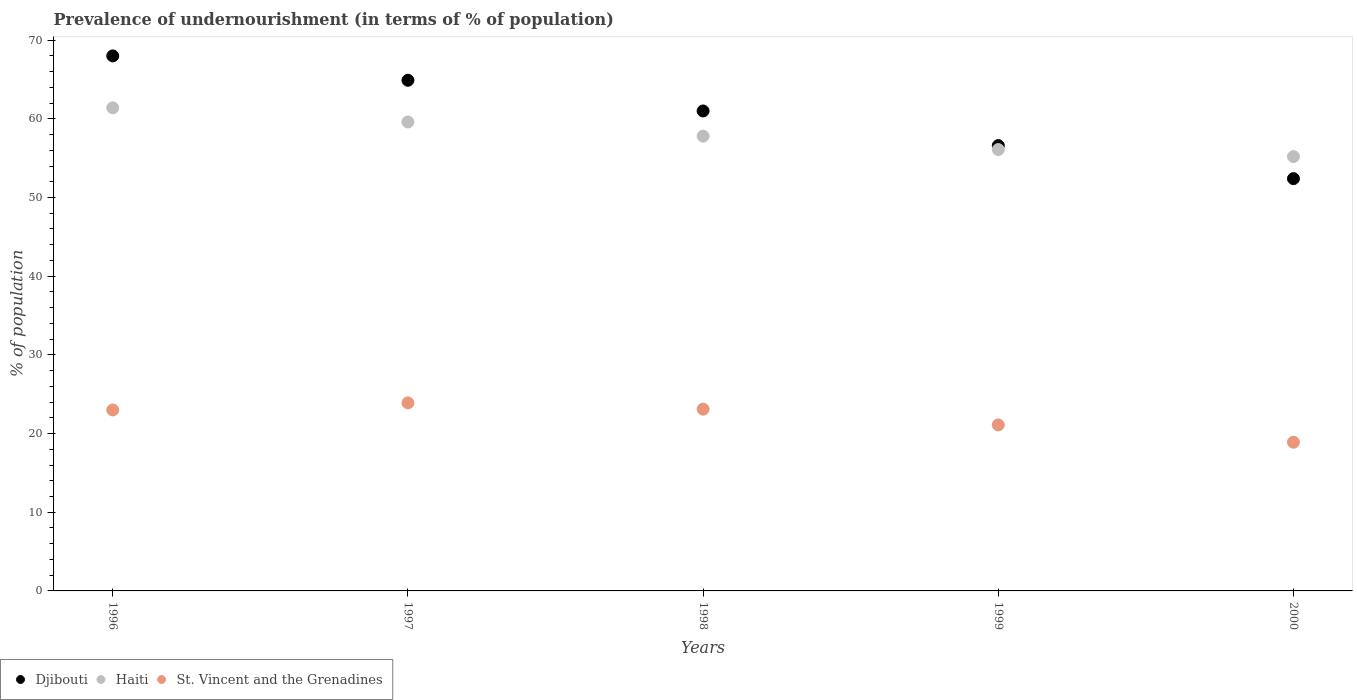Is the number of dotlines equal to the number of legend labels?
Give a very brief answer. Yes. What is the percentage of undernourished population in Haiti in 1997?
Your answer should be compact. 59.6. Across all years, what is the maximum percentage of undernourished population in St. Vincent and the Grenadines?
Offer a very short reply. 23.9. Across all years, what is the minimum percentage of undernourished population in Djibouti?
Your answer should be compact. 52.4. In which year was the percentage of undernourished population in Djibouti minimum?
Provide a succinct answer. 2000. What is the total percentage of undernourished population in Djibouti in the graph?
Your answer should be very brief. 302.9. What is the difference between the percentage of undernourished population in St. Vincent and the Grenadines in 1996 and that in 1999?
Your answer should be very brief. 1.9. What is the difference between the percentage of undernourished population in Djibouti in 1999 and the percentage of undernourished population in St. Vincent and the Grenadines in 1996?
Make the answer very short. 33.6. What is the average percentage of undernourished population in Haiti per year?
Your answer should be very brief. 58.02. In the year 1999, what is the difference between the percentage of undernourished population in Haiti and percentage of undernourished population in St. Vincent and the Grenadines?
Keep it short and to the point. 35. In how many years, is the percentage of undernourished population in Djibouti greater than 56 %?
Give a very brief answer. 4. What is the ratio of the percentage of undernourished population in St. Vincent and the Grenadines in 1997 to that in 1998?
Offer a terse response. 1.03. What is the difference between the highest and the second highest percentage of undernourished population in Haiti?
Offer a very short reply. 1.8. What is the difference between the highest and the lowest percentage of undernourished population in Haiti?
Your answer should be compact. 6.2. In how many years, is the percentage of undernourished population in Djibouti greater than the average percentage of undernourished population in Djibouti taken over all years?
Offer a terse response. 3. Is the sum of the percentage of undernourished population in Djibouti in 1997 and 1998 greater than the maximum percentage of undernourished population in Haiti across all years?
Your answer should be very brief. Yes. Does the percentage of undernourished population in Djibouti monotonically increase over the years?
Provide a short and direct response. No. Is the percentage of undernourished population in Haiti strictly less than the percentage of undernourished population in St. Vincent and the Grenadines over the years?
Offer a very short reply. No. How many dotlines are there?
Provide a short and direct response. 3. How many years are there in the graph?
Your answer should be compact. 5. What is the difference between two consecutive major ticks on the Y-axis?
Give a very brief answer. 10. Are the values on the major ticks of Y-axis written in scientific E-notation?
Keep it short and to the point. No. Does the graph contain any zero values?
Provide a succinct answer. No. Does the graph contain grids?
Make the answer very short. No. Where does the legend appear in the graph?
Offer a terse response. Bottom left. How are the legend labels stacked?
Offer a terse response. Horizontal. What is the title of the graph?
Make the answer very short. Prevalence of undernourishment (in terms of % of population). Does "Eritrea" appear as one of the legend labels in the graph?
Make the answer very short. No. What is the label or title of the Y-axis?
Your answer should be compact. % of population. What is the % of population of Haiti in 1996?
Ensure brevity in your answer.  61.4. What is the % of population of St. Vincent and the Grenadines in 1996?
Offer a very short reply. 23. What is the % of population of Djibouti in 1997?
Provide a short and direct response. 64.9. What is the % of population in Haiti in 1997?
Offer a very short reply. 59.6. What is the % of population in St. Vincent and the Grenadines in 1997?
Keep it short and to the point. 23.9. What is the % of population in Haiti in 1998?
Make the answer very short. 57.8. What is the % of population of St. Vincent and the Grenadines in 1998?
Give a very brief answer. 23.1. What is the % of population of Djibouti in 1999?
Make the answer very short. 56.6. What is the % of population of Haiti in 1999?
Your answer should be very brief. 56.1. What is the % of population of St. Vincent and the Grenadines in 1999?
Your response must be concise. 21.1. What is the % of population of Djibouti in 2000?
Your answer should be very brief. 52.4. What is the % of population in Haiti in 2000?
Ensure brevity in your answer.  55.2. Across all years, what is the maximum % of population of Djibouti?
Provide a succinct answer. 68. Across all years, what is the maximum % of population of Haiti?
Provide a succinct answer. 61.4. Across all years, what is the maximum % of population of St. Vincent and the Grenadines?
Offer a very short reply. 23.9. Across all years, what is the minimum % of population in Djibouti?
Provide a short and direct response. 52.4. Across all years, what is the minimum % of population in Haiti?
Keep it short and to the point. 55.2. What is the total % of population of Djibouti in the graph?
Offer a terse response. 302.9. What is the total % of population of Haiti in the graph?
Provide a short and direct response. 290.1. What is the total % of population in St. Vincent and the Grenadines in the graph?
Your answer should be compact. 110. What is the difference between the % of population of Haiti in 1996 and that in 1997?
Your answer should be very brief. 1.8. What is the difference between the % of population in St. Vincent and the Grenadines in 1996 and that in 1997?
Ensure brevity in your answer.  -0.9. What is the difference between the % of population in Djibouti in 1996 and that in 1998?
Provide a short and direct response. 7. What is the difference between the % of population in Haiti in 1996 and that in 1998?
Provide a short and direct response. 3.6. What is the difference between the % of population in St. Vincent and the Grenadines in 1996 and that in 1998?
Keep it short and to the point. -0.1. What is the difference between the % of population of Djibouti in 1996 and that in 2000?
Provide a succinct answer. 15.6. What is the difference between the % of population in Djibouti in 1997 and that in 1998?
Provide a short and direct response. 3.9. What is the difference between the % of population in St. Vincent and the Grenadines in 1997 and that in 2000?
Ensure brevity in your answer.  5. What is the difference between the % of population in Haiti in 1998 and that in 1999?
Your answer should be compact. 1.7. What is the difference between the % of population in St. Vincent and the Grenadines in 1998 and that in 1999?
Offer a very short reply. 2. What is the difference between the % of population in Djibouti in 1998 and that in 2000?
Provide a succinct answer. 8.6. What is the difference between the % of population in St. Vincent and the Grenadines in 1998 and that in 2000?
Provide a short and direct response. 4.2. What is the difference between the % of population of St. Vincent and the Grenadines in 1999 and that in 2000?
Ensure brevity in your answer.  2.2. What is the difference between the % of population of Djibouti in 1996 and the % of population of St. Vincent and the Grenadines in 1997?
Ensure brevity in your answer.  44.1. What is the difference between the % of population in Haiti in 1996 and the % of population in St. Vincent and the Grenadines in 1997?
Offer a very short reply. 37.5. What is the difference between the % of population in Djibouti in 1996 and the % of population in St. Vincent and the Grenadines in 1998?
Your answer should be compact. 44.9. What is the difference between the % of population in Haiti in 1996 and the % of population in St. Vincent and the Grenadines in 1998?
Give a very brief answer. 38.3. What is the difference between the % of population of Djibouti in 1996 and the % of population of Haiti in 1999?
Ensure brevity in your answer.  11.9. What is the difference between the % of population in Djibouti in 1996 and the % of population in St. Vincent and the Grenadines in 1999?
Your answer should be very brief. 46.9. What is the difference between the % of population in Haiti in 1996 and the % of population in St. Vincent and the Grenadines in 1999?
Offer a terse response. 40.3. What is the difference between the % of population of Djibouti in 1996 and the % of population of Haiti in 2000?
Your answer should be compact. 12.8. What is the difference between the % of population of Djibouti in 1996 and the % of population of St. Vincent and the Grenadines in 2000?
Your answer should be very brief. 49.1. What is the difference between the % of population of Haiti in 1996 and the % of population of St. Vincent and the Grenadines in 2000?
Keep it short and to the point. 42.5. What is the difference between the % of population of Djibouti in 1997 and the % of population of Haiti in 1998?
Keep it short and to the point. 7.1. What is the difference between the % of population in Djibouti in 1997 and the % of population in St. Vincent and the Grenadines in 1998?
Provide a short and direct response. 41.8. What is the difference between the % of population of Haiti in 1997 and the % of population of St. Vincent and the Grenadines in 1998?
Your answer should be very brief. 36.5. What is the difference between the % of population of Djibouti in 1997 and the % of population of Haiti in 1999?
Your answer should be compact. 8.8. What is the difference between the % of population of Djibouti in 1997 and the % of population of St. Vincent and the Grenadines in 1999?
Keep it short and to the point. 43.8. What is the difference between the % of population in Haiti in 1997 and the % of population in St. Vincent and the Grenadines in 1999?
Your answer should be compact. 38.5. What is the difference between the % of population of Djibouti in 1997 and the % of population of Haiti in 2000?
Your answer should be compact. 9.7. What is the difference between the % of population in Djibouti in 1997 and the % of population in St. Vincent and the Grenadines in 2000?
Your answer should be very brief. 46. What is the difference between the % of population of Haiti in 1997 and the % of population of St. Vincent and the Grenadines in 2000?
Offer a very short reply. 40.7. What is the difference between the % of population of Djibouti in 1998 and the % of population of Haiti in 1999?
Your answer should be very brief. 4.9. What is the difference between the % of population in Djibouti in 1998 and the % of population in St. Vincent and the Grenadines in 1999?
Give a very brief answer. 39.9. What is the difference between the % of population in Haiti in 1998 and the % of population in St. Vincent and the Grenadines in 1999?
Offer a very short reply. 36.7. What is the difference between the % of population in Djibouti in 1998 and the % of population in St. Vincent and the Grenadines in 2000?
Offer a very short reply. 42.1. What is the difference between the % of population in Haiti in 1998 and the % of population in St. Vincent and the Grenadines in 2000?
Ensure brevity in your answer.  38.9. What is the difference between the % of population of Djibouti in 1999 and the % of population of St. Vincent and the Grenadines in 2000?
Give a very brief answer. 37.7. What is the difference between the % of population in Haiti in 1999 and the % of population in St. Vincent and the Grenadines in 2000?
Your response must be concise. 37.2. What is the average % of population of Djibouti per year?
Provide a short and direct response. 60.58. What is the average % of population of Haiti per year?
Give a very brief answer. 58.02. In the year 1996, what is the difference between the % of population in Djibouti and % of population in Haiti?
Your answer should be compact. 6.6. In the year 1996, what is the difference between the % of population of Haiti and % of population of St. Vincent and the Grenadines?
Your response must be concise. 38.4. In the year 1997, what is the difference between the % of population in Djibouti and % of population in Haiti?
Offer a very short reply. 5.3. In the year 1997, what is the difference between the % of population in Djibouti and % of population in St. Vincent and the Grenadines?
Provide a succinct answer. 41. In the year 1997, what is the difference between the % of population in Haiti and % of population in St. Vincent and the Grenadines?
Keep it short and to the point. 35.7. In the year 1998, what is the difference between the % of population in Djibouti and % of population in Haiti?
Give a very brief answer. 3.2. In the year 1998, what is the difference between the % of population in Djibouti and % of population in St. Vincent and the Grenadines?
Offer a terse response. 37.9. In the year 1998, what is the difference between the % of population of Haiti and % of population of St. Vincent and the Grenadines?
Make the answer very short. 34.7. In the year 1999, what is the difference between the % of population in Djibouti and % of population in Haiti?
Offer a terse response. 0.5. In the year 1999, what is the difference between the % of population in Djibouti and % of population in St. Vincent and the Grenadines?
Provide a short and direct response. 35.5. In the year 1999, what is the difference between the % of population in Haiti and % of population in St. Vincent and the Grenadines?
Provide a succinct answer. 35. In the year 2000, what is the difference between the % of population of Djibouti and % of population of St. Vincent and the Grenadines?
Make the answer very short. 33.5. In the year 2000, what is the difference between the % of population of Haiti and % of population of St. Vincent and the Grenadines?
Your answer should be very brief. 36.3. What is the ratio of the % of population in Djibouti in 1996 to that in 1997?
Your response must be concise. 1.05. What is the ratio of the % of population of Haiti in 1996 to that in 1997?
Your answer should be compact. 1.03. What is the ratio of the % of population of St. Vincent and the Grenadines in 1996 to that in 1997?
Make the answer very short. 0.96. What is the ratio of the % of population of Djibouti in 1996 to that in 1998?
Give a very brief answer. 1.11. What is the ratio of the % of population in Haiti in 1996 to that in 1998?
Make the answer very short. 1.06. What is the ratio of the % of population in St. Vincent and the Grenadines in 1996 to that in 1998?
Provide a short and direct response. 1. What is the ratio of the % of population in Djibouti in 1996 to that in 1999?
Your response must be concise. 1.2. What is the ratio of the % of population in Haiti in 1996 to that in 1999?
Ensure brevity in your answer.  1.09. What is the ratio of the % of population of St. Vincent and the Grenadines in 1996 to that in 1999?
Give a very brief answer. 1.09. What is the ratio of the % of population of Djibouti in 1996 to that in 2000?
Your answer should be compact. 1.3. What is the ratio of the % of population of Haiti in 1996 to that in 2000?
Give a very brief answer. 1.11. What is the ratio of the % of population of St. Vincent and the Grenadines in 1996 to that in 2000?
Your answer should be compact. 1.22. What is the ratio of the % of population of Djibouti in 1997 to that in 1998?
Provide a succinct answer. 1.06. What is the ratio of the % of population of Haiti in 1997 to that in 1998?
Provide a succinct answer. 1.03. What is the ratio of the % of population in St. Vincent and the Grenadines in 1997 to that in 1998?
Ensure brevity in your answer.  1.03. What is the ratio of the % of population in Djibouti in 1997 to that in 1999?
Your answer should be very brief. 1.15. What is the ratio of the % of population in Haiti in 1997 to that in 1999?
Your answer should be compact. 1.06. What is the ratio of the % of population of St. Vincent and the Grenadines in 1997 to that in 1999?
Your response must be concise. 1.13. What is the ratio of the % of population of Djibouti in 1997 to that in 2000?
Make the answer very short. 1.24. What is the ratio of the % of population of Haiti in 1997 to that in 2000?
Provide a succinct answer. 1.08. What is the ratio of the % of population of St. Vincent and the Grenadines in 1997 to that in 2000?
Ensure brevity in your answer.  1.26. What is the ratio of the % of population of Djibouti in 1998 to that in 1999?
Your answer should be compact. 1.08. What is the ratio of the % of population of Haiti in 1998 to that in 1999?
Give a very brief answer. 1.03. What is the ratio of the % of population of St. Vincent and the Grenadines in 1998 to that in 1999?
Your response must be concise. 1.09. What is the ratio of the % of population in Djibouti in 1998 to that in 2000?
Make the answer very short. 1.16. What is the ratio of the % of population of Haiti in 1998 to that in 2000?
Provide a short and direct response. 1.05. What is the ratio of the % of population of St. Vincent and the Grenadines in 1998 to that in 2000?
Offer a terse response. 1.22. What is the ratio of the % of population in Djibouti in 1999 to that in 2000?
Give a very brief answer. 1.08. What is the ratio of the % of population of Haiti in 1999 to that in 2000?
Give a very brief answer. 1.02. What is the ratio of the % of population in St. Vincent and the Grenadines in 1999 to that in 2000?
Your answer should be very brief. 1.12. What is the difference between the highest and the second highest % of population of Djibouti?
Provide a succinct answer. 3.1. What is the difference between the highest and the second highest % of population of St. Vincent and the Grenadines?
Offer a terse response. 0.8. 